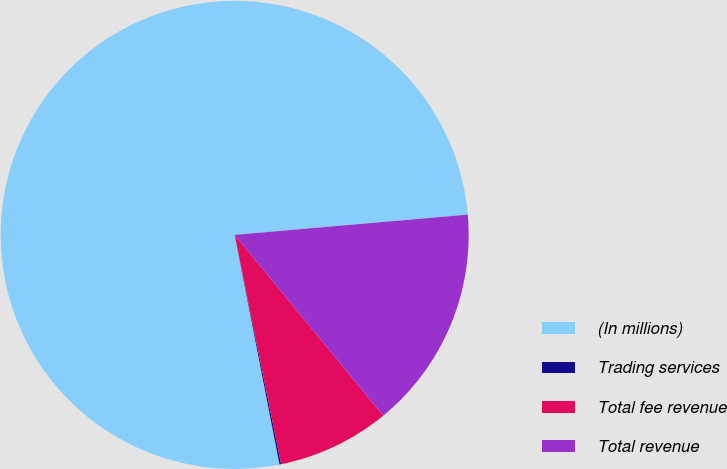<chart> <loc_0><loc_0><loc_500><loc_500><pie_chart><fcel>(In millions)<fcel>Trading services<fcel>Total fee revenue<fcel>Total revenue<nl><fcel>76.69%<fcel>0.11%<fcel>7.77%<fcel>15.43%<nl></chart> 